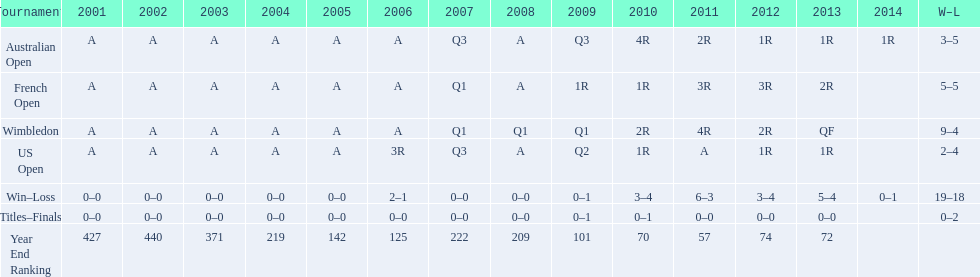What was this athlete's average rating between 2001 and 2006? 287. 